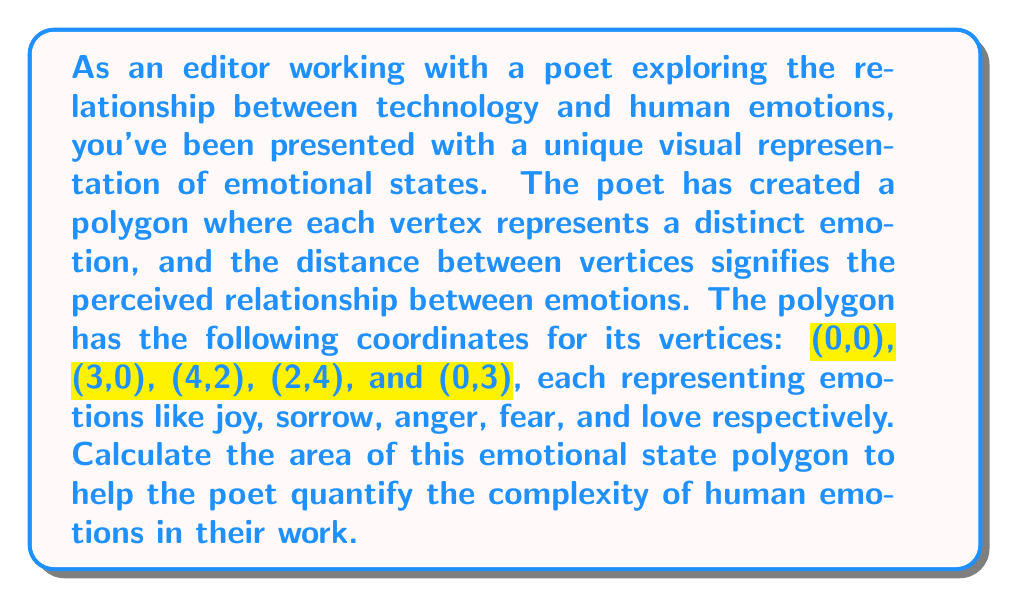Teach me how to tackle this problem. To calculate the area of this irregular polygon, we can use the Shoelace formula (also known as the surveyor's formula). This method is particularly useful for polygons with known vertex coordinates.

The Shoelace formula for a polygon with $n$ vertices $(x_1, y_1), (x_2, y_2), ..., (x_n, y_n)$ is:

$$A = \frac{1}{2}|(x_1y_2 + x_2y_3 + ... + x_ny_1) - (y_1x_2 + y_2x_3 + ... + y_nx_1)|$$

Let's apply this to our polygon:

1) First, let's list our vertices in order:
   (0,0), (3,0), (4,2), (2,4), (0,3)

2) Now, let's calculate the first part of the formula:
   $(0 \cdot 0) + (3 \cdot 2) + (4 \cdot 4) + (2 \cdot 3) + (0 \cdot 0) = 0 + 6 + 16 + 6 + 0 = 28$

3) Next, calculate the second part:
   $(0 \cdot 3) + (0 \cdot 4) + (2 \cdot 2) + (4 \cdot 0) + (3 \cdot 0) = 0 + 0 + 4 + 0 + 0 = 4$

4) Subtract the second part from the first:
   $28 - 4 = 24$

5) Finally, divide by 2:
   $\frac{24}{2} = 12$

Therefore, the area of the emotional state polygon is 12 square units.

[asy]
unitsize(1cm);
draw((0,0)--(3,0)--(4,2)--(2,4)--(0,3)--cycle);
label("(0,0)", (0,0), SW);
label("(3,0)", (3,0), SE);
label("(4,2)", (4,2), E);
label("(2,4)", (2,4), N);
label("(0,3)", (0,3), W);
[/asy]
Answer: The area of the emotional state polygon is 12 square units. 